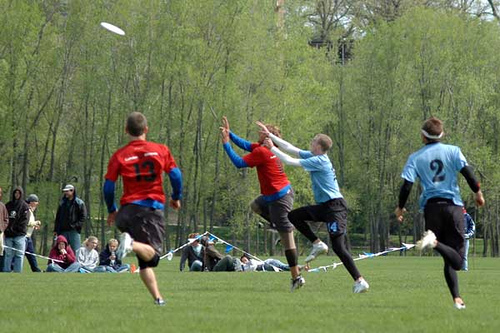What sport are the people playing? The individuals in the image seem to be playing Ultimate Frisbee, a team sport that involves passing a disc with the aim of catching it in the opposing team's end zone. 